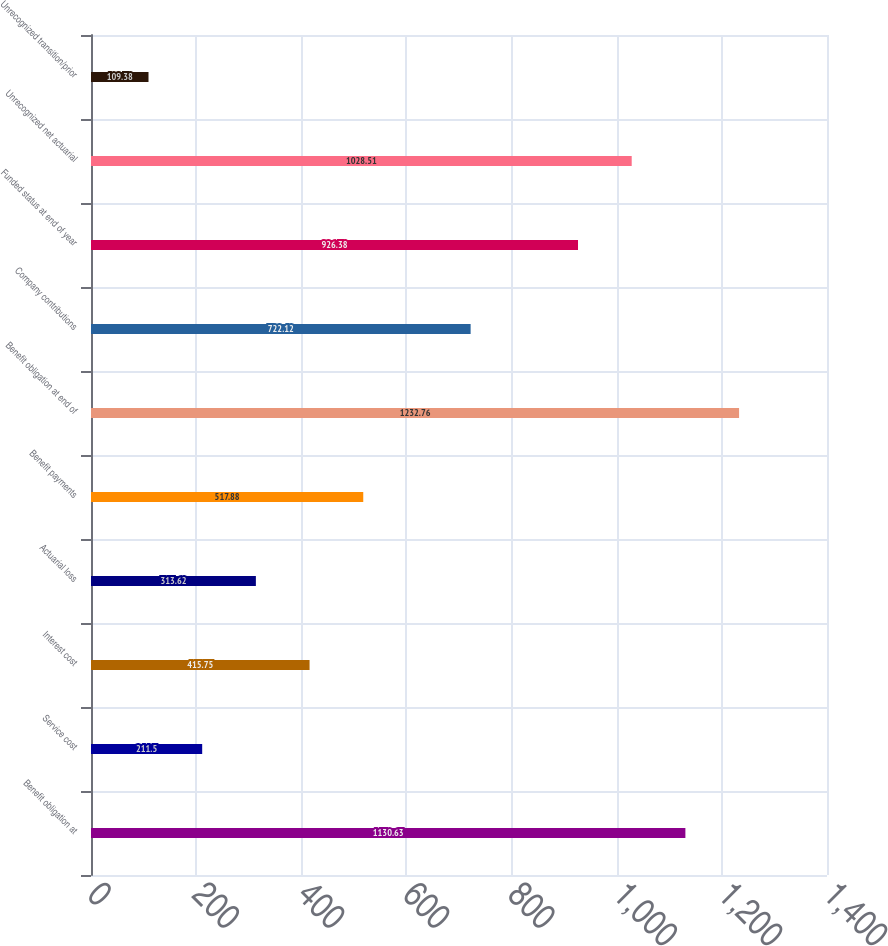<chart> <loc_0><loc_0><loc_500><loc_500><bar_chart><fcel>Benefit obligation at<fcel>Service cost<fcel>Interest cost<fcel>Actuarial loss<fcel>Benefit payments<fcel>Benefit obligation at end of<fcel>Company contributions<fcel>Funded status at end of year<fcel>Unrecognized net actuarial<fcel>Unrecognized transition/prior<nl><fcel>1130.63<fcel>211.5<fcel>415.75<fcel>313.62<fcel>517.88<fcel>1232.76<fcel>722.12<fcel>926.38<fcel>1028.51<fcel>109.38<nl></chart> 